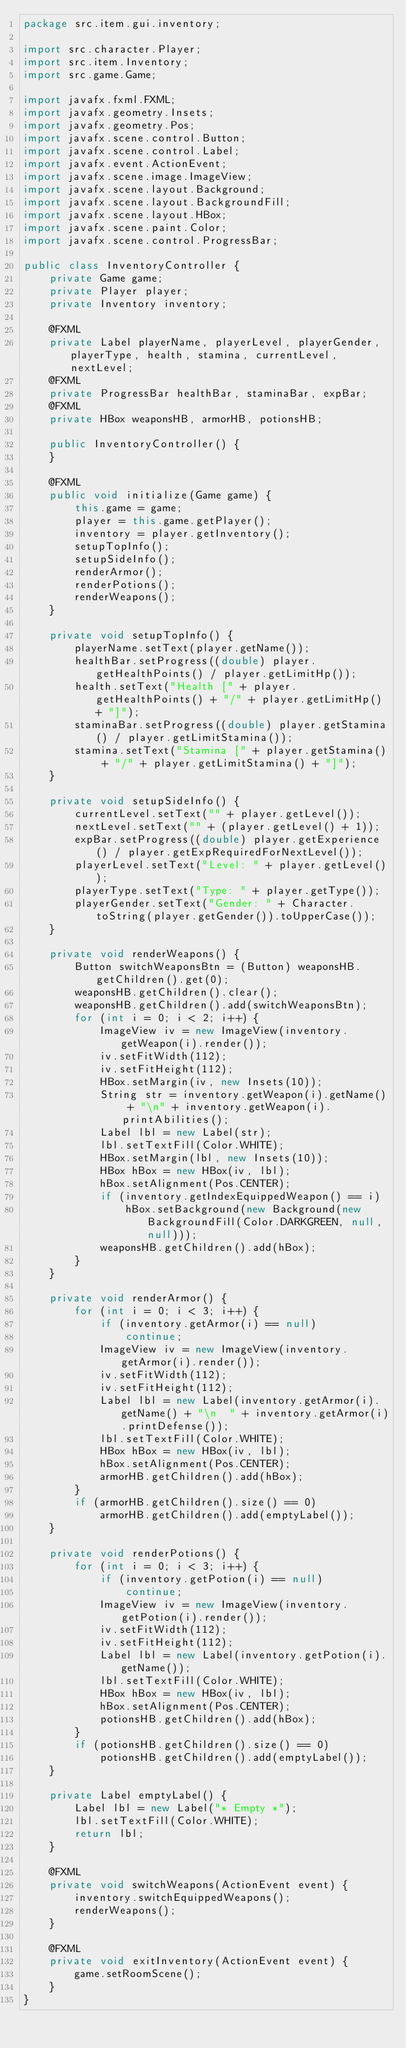Convert code to text. <code><loc_0><loc_0><loc_500><loc_500><_Java_>package src.item.gui.inventory;

import src.character.Player;
import src.item.Inventory;
import src.game.Game;

import javafx.fxml.FXML;
import javafx.geometry.Insets;
import javafx.geometry.Pos;
import javafx.scene.control.Button;
import javafx.scene.control.Label;
import javafx.event.ActionEvent;
import javafx.scene.image.ImageView;
import javafx.scene.layout.Background;
import javafx.scene.layout.BackgroundFill;
import javafx.scene.layout.HBox;
import javafx.scene.paint.Color;
import javafx.scene.control.ProgressBar;

public class InventoryController {
    private Game game;
    private Player player;
    private Inventory inventory;

    @FXML
    private Label playerName, playerLevel, playerGender, playerType, health, stamina, currentLevel, nextLevel;
    @FXML
    private ProgressBar healthBar, staminaBar, expBar;
    @FXML
    private HBox weaponsHB, armorHB, potionsHB;

    public InventoryController() {
    }

    @FXML
    public void initialize(Game game) {
        this.game = game;
        player = this.game.getPlayer();
        inventory = player.getInventory();
        setupTopInfo();
        setupSideInfo();
        renderArmor();
        renderPotions();
        renderWeapons();
    }

    private void setupTopInfo() {
        playerName.setText(player.getName());
        healthBar.setProgress((double) player.getHealthPoints() / player.getLimitHp());
        health.setText("Health [" + player.getHealthPoints() + "/" + player.getLimitHp() + "]");
        staminaBar.setProgress((double) player.getStamina() / player.getLimitStamina());
        stamina.setText("Stamina [" + player.getStamina() + "/" + player.getLimitStamina() + "]");
    }

    private void setupSideInfo() {
        currentLevel.setText("" + player.getLevel());
        nextLevel.setText("" + (player.getLevel() + 1));
        expBar.setProgress((double) player.getExperience() / player.getExpRequiredForNextLevel());
        playerLevel.setText("Level: " + player.getLevel());
        playerType.setText("Type: " + player.getType());
        playerGender.setText("Gender: " + Character.toString(player.getGender()).toUpperCase());
    }

    private void renderWeapons() {
        Button switchWeaponsBtn = (Button) weaponsHB.getChildren().get(0);
        weaponsHB.getChildren().clear();
        weaponsHB.getChildren().add(switchWeaponsBtn);
        for (int i = 0; i < 2; i++) {
            ImageView iv = new ImageView(inventory.getWeapon(i).render());
            iv.setFitWidth(112);
            iv.setFitHeight(112);
            HBox.setMargin(iv, new Insets(10));
            String str = inventory.getWeapon(i).getName() + "\n" + inventory.getWeapon(i).printAbilities();
            Label lbl = new Label(str);
            lbl.setTextFill(Color.WHITE);
            HBox.setMargin(lbl, new Insets(10));
            HBox hBox = new HBox(iv, lbl);
            hBox.setAlignment(Pos.CENTER);
            if (inventory.getIndexEquippedWeapon() == i)
                hBox.setBackground(new Background(new BackgroundFill(Color.DARKGREEN, null, null)));
            weaponsHB.getChildren().add(hBox);
        }
    }

    private void renderArmor() {
        for (int i = 0; i < 3; i++) {
            if (inventory.getArmor(i) == null)
                continue;
            ImageView iv = new ImageView(inventory.getArmor(i).render());
            iv.setFitWidth(112);
            iv.setFitHeight(112);
            Label lbl = new Label(inventory.getArmor(i).getName() + "\n  " + inventory.getArmor(i).printDefense());
            lbl.setTextFill(Color.WHITE);
            HBox hBox = new HBox(iv, lbl);
            hBox.setAlignment(Pos.CENTER);
            armorHB.getChildren().add(hBox);
        }
        if (armorHB.getChildren().size() == 0)
            armorHB.getChildren().add(emptyLabel());
    }

    private void renderPotions() {
        for (int i = 0; i < 3; i++) {
            if (inventory.getPotion(i) == null)
                continue;
            ImageView iv = new ImageView(inventory.getPotion(i).render());
            iv.setFitWidth(112);
            iv.setFitHeight(112);
            Label lbl = new Label(inventory.getPotion(i).getName());
            lbl.setTextFill(Color.WHITE);
            HBox hBox = new HBox(iv, lbl);
            hBox.setAlignment(Pos.CENTER);
            potionsHB.getChildren().add(hBox);
        }
        if (potionsHB.getChildren().size() == 0)
            potionsHB.getChildren().add(emptyLabel());
    }

    private Label emptyLabel() {
        Label lbl = new Label("* Empty *");
        lbl.setTextFill(Color.WHITE);
        return lbl;
    }

    @FXML
    private void switchWeapons(ActionEvent event) {
        inventory.switchEquippedWeapons();
        renderWeapons();
    }

    @FXML
    private void exitInventory(ActionEvent event) {
        game.setRoomScene();
    }
}
</code> 